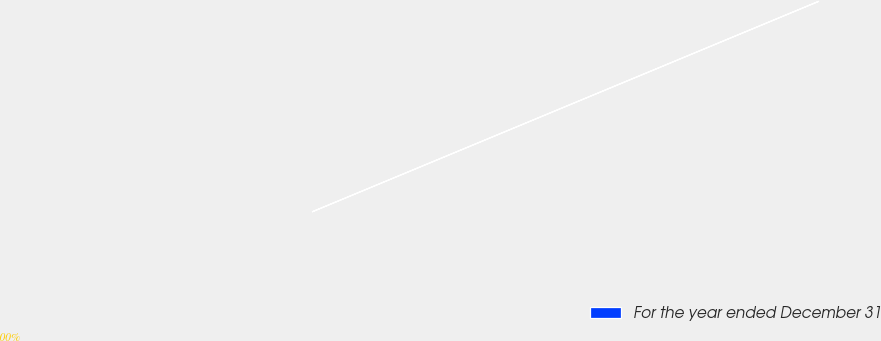Convert chart to OTSL. <chart><loc_0><loc_0><loc_500><loc_500><pie_chart><fcel>For the year ended December 31<nl><fcel>100.0%<nl></chart> 